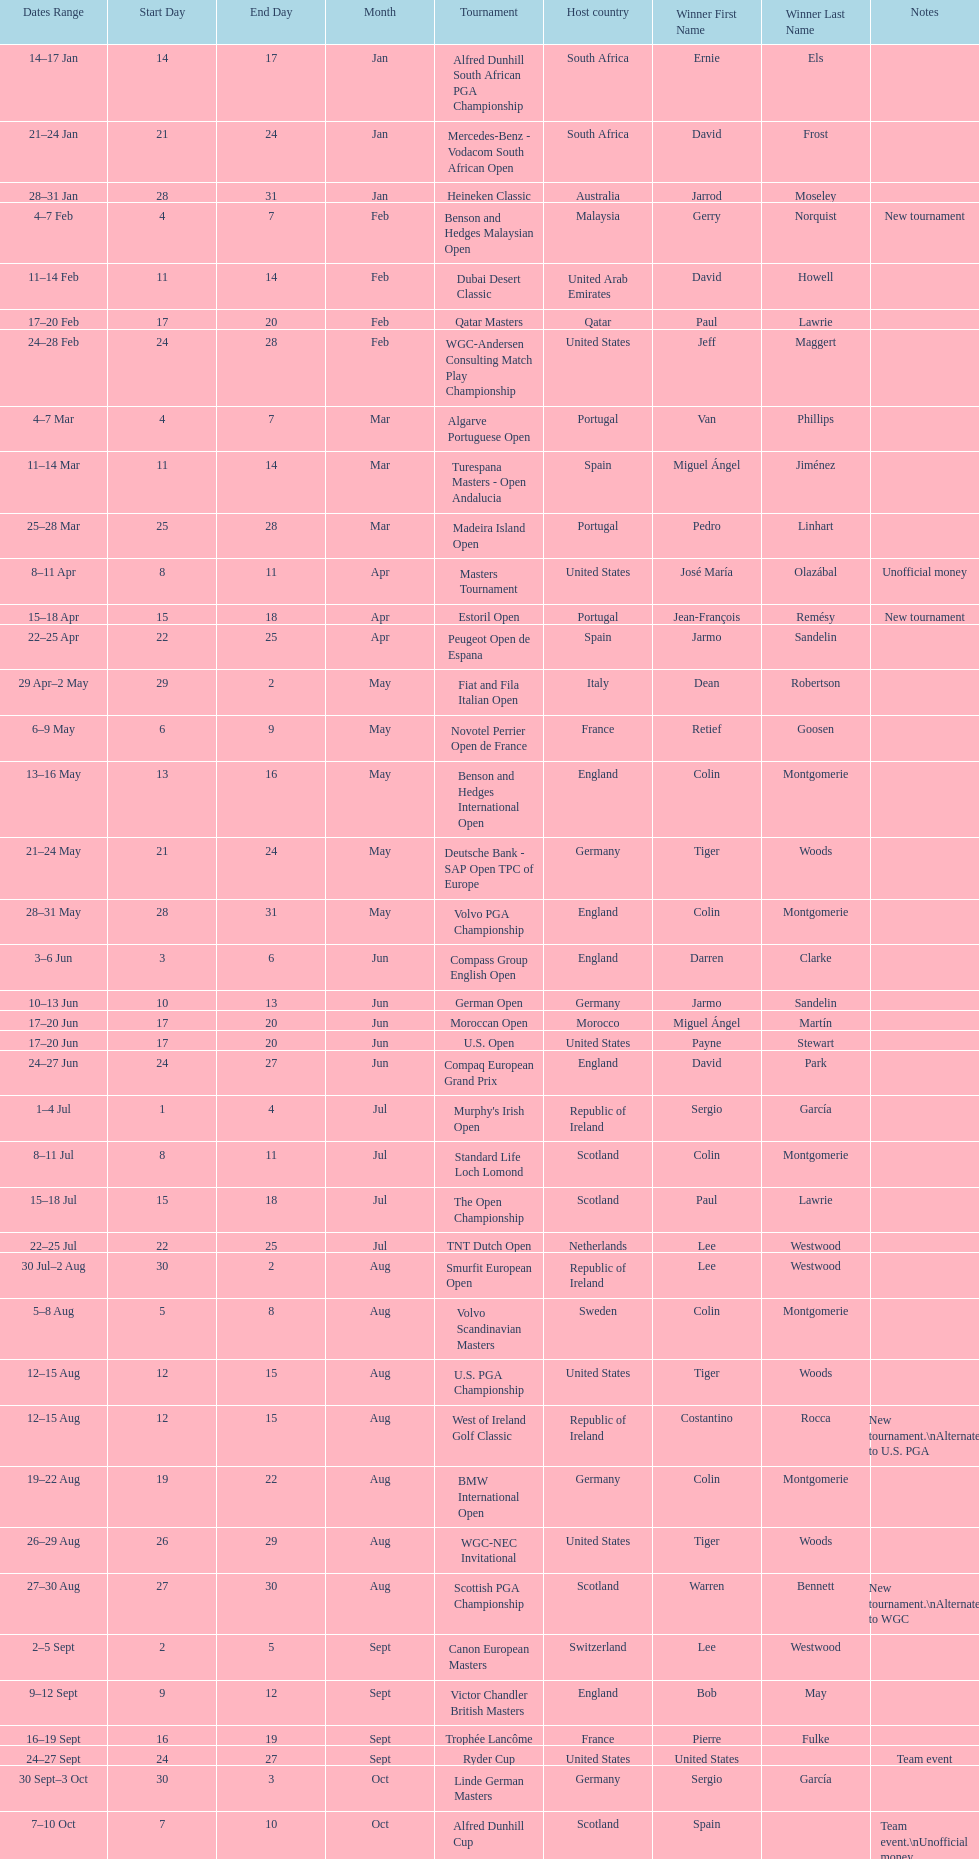Other than qatar masters, name a tournament that was in february. Dubai Desert Classic. 